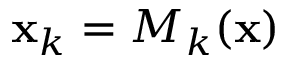Convert formula to latex. <formula><loc_0><loc_0><loc_500><loc_500>{ x } _ { k } = M _ { k } ( { x } )</formula> 